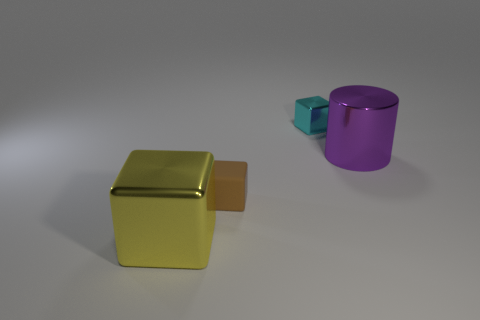Add 2 brown matte cubes. How many objects exist? 6 Subtract all cubes. How many objects are left? 1 Subtract 1 yellow cubes. How many objects are left? 3 Subtract all large green metallic cylinders. Subtract all purple cylinders. How many objects are left? 3 Add 1 brown matte things. How many brown matte things are left? 2 Add 3 small brown blocks. How many small brown blocks exist? 4 